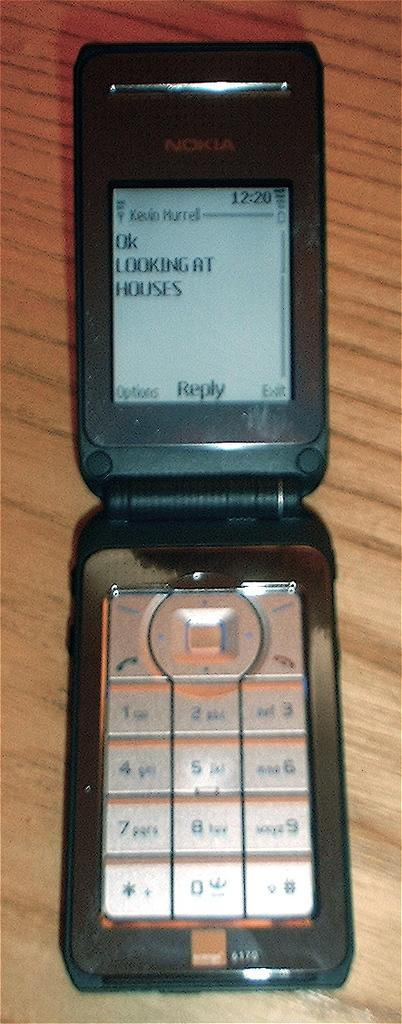<image>
Present a compact description of the photo's key features. A flip cellphone by Nokia that is open with a text that says Ok Looking At Houses 